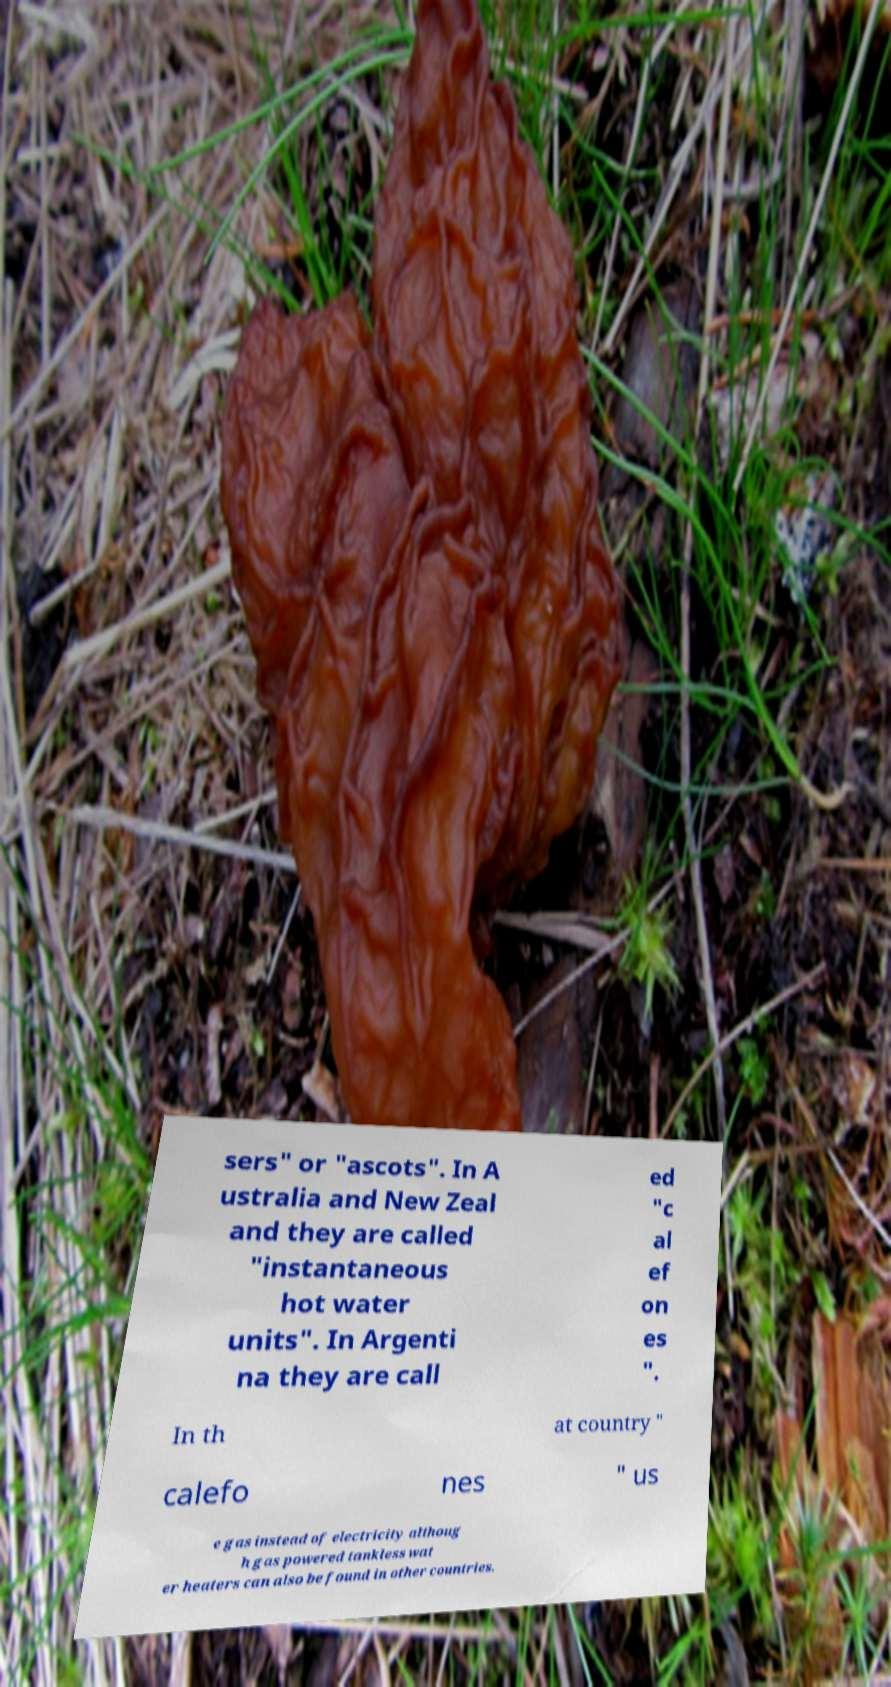Please identify and transcribe the text found in this image. sers" or "ascots". In A ustralia and New Zeal and they are called "instantaneous hot water units". In Argenti na they are call ed "c al ef on es ". In th at country " calefo nes " us e gas instead of electricity althoug h gas powered tankless wat er heaters can also be found in other countries. 